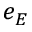Convert formula to latex. <formula><loc_0><loc_0><loc_500><loc_500>e _ { E }</formula> 